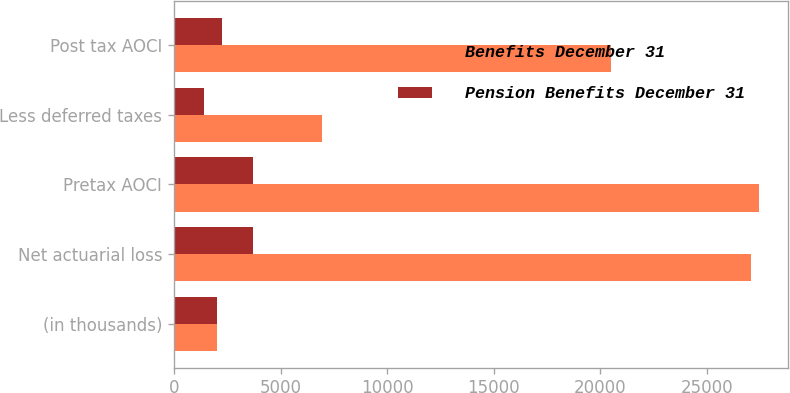<chart> <loc_0><loc_0><loc_500><loc_500><stacked_bar_chart><ecel><fcel>(in thousands)<fcel>Net actuarial loss<fcel>Pretax AOCI<fcel>Less deferred taxes<fcel>Post tax AOCI<nl><fcel>Benefits December 31<fcel>2009<fcel>27056<fcel>27443<fcel>6939<fcel>20504<nl><fcel>Pension Benefits December 31<fcel>2009<fcel>3697<fcel>3697<fcel>1427<fcel>2270<nl></chart> 